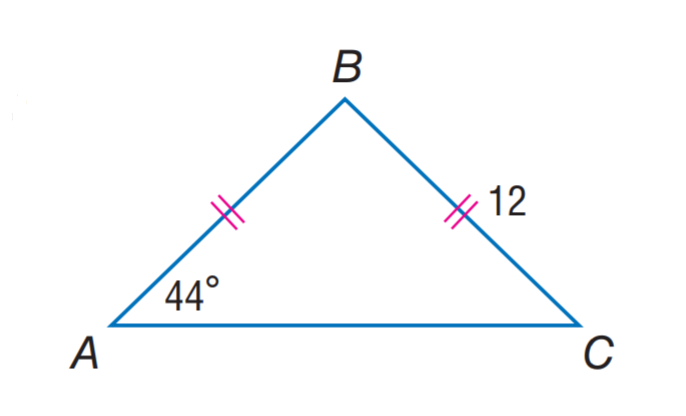Answer the mathemtical geometry problem and directly provide the correct option letter.
Question: Find m \angle B.
Choices: A: 44 B: 89 C: 92 D: 98 C 